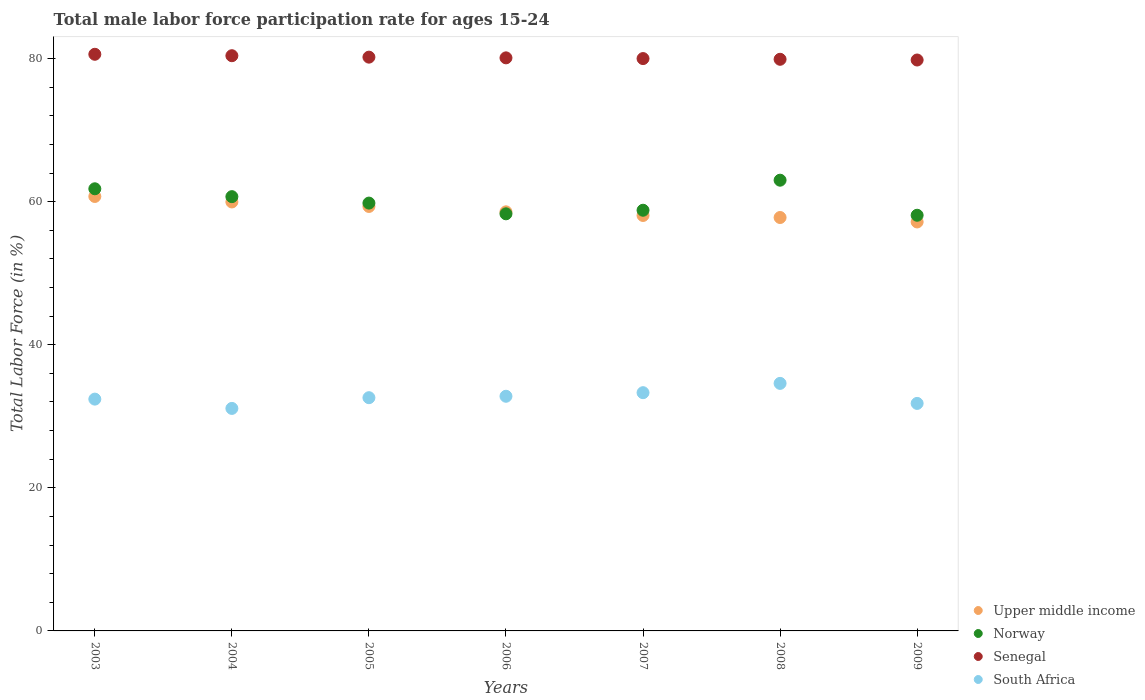What is the male labor force participation rate in Norway in 2005?
Give a very brief answer. 59.8. Across all years, what is the maximum male labor force participation rate in Senegal?
Your answer should be very brief. 80.6. Across all years, what is the minimum male labor force participation rate in Upper middle income?
Your answer should be compact. 57.16. What is the total male labor force participation rate in Senegal in the graph?
Offer a very short reply. 561. What is the difference between the male labor force participation rate in Norway in 2005 and that in 2008?
Provide a succinct answer. -3.2. What is the difference between the male labor force participation rate in Norway in 2006 and the male labor force participation rate in Senegal in 2005?
Your response must be concise. -21.9. What is the average male labor force participation rate in South Africa per year?
Provide a succinct answer. 32.66. In the year 2005, what is the difference between the male labor force participation rate in Upper middle income and male labor force participation rate in Senegal?
Your answer should be very brief. -20.87. What is the ratio of the male labor force participation rate in Norway in 2003 to that in 2005?
Ensure brevity in your answer.  1.03. Is the male labor force participation rate in South Africa in 2005 less than that in 2006?
Offer a terse response. Yes. Is the difference between the male labor force participation rate in Upper middle income in 2006 and 2007 greater than the difference between the male labor force participation rate in Senegal in 2006 and 2007?
Provide a short and direct response. Yes. What is the difference between the highest and the second highest male labor force participation rate in Upper middle income?
Provide a succinct answer. 0.77. What is the difference between the highest and the lowest male labor force participation rate in Norway?
Your response must be concise. 4.9. Is it the case that in every year, the sum of the male labor force participation rate in Senegal and male labor force participation rate in Upper middle income  is greater than the sum of male labor force participation rate in South Africa and male labor force participation rate in Norway?
Offer a terse response. No. Is it the case that in every year, the sum of the male labor force participation rate in South Africa and male labor force participation rate in Senegal  is greater than the male labor force participation rate in Upper middle income?
Offer a very short reply. Yes. Is the male labor force participation rate in Senegal strictly greater than the male labor force participation rate in South Africa over the years?
Give a very brief answer. Yes. How many years are there in the graph?
Provide a succinct answer. 7. Are the values on the major ticks of Y-axis written in scientific E-notation?
Give a very brief answer. No. Does the graph contain any zero values?
Your response must be concise. No. Does the graph contain grids?
Offer a terse response. No. Where does the legend appear in the graph?
Keep it short and to the point. Bottom right. What is the title of the graph?
Provide a succinct answer. Total male labor force participation rate for ages 15-24. Does "Qatar" appear as one of the legend labels in the graph?
Ensure brevity in your answer.  No. What is the label or title of the X-axis?
Ensure brevity in your answer.  Years. What is the label or title of the Y-axis?
Provide a short and direct response. Total Labor Force (in %). What is the Total Labor Force (in %) of Upper middle income in 2003?
Provide a succinct answer. 60.73. What is the Total Labor Force (in %) in Norway in 2003?
Your answer should be very brief. 61.8. What is the Total Labor Force (in %) in Senegal in 2003?
Your answer should be very brief. 80.6. What is the Total Labor Force (in %) in South Africa in 2003?
Provide a short and direct response. 32.4. What is the Total Labor Force (in %) in Upper middle income in 2004?
Give a very brief answer. 59.96. What is the Total Labor Force (in %) of Norway in 2004?
Offer a very short reply. 60.7. What is the Total Labor Force (in %) of Senegal in 2004?
Your answer should be compact. 80.4. What is the Total Labor Force (in %) in South Africa in 2004?
Provide a succinct answer. 31.1. What is the Total Labor Force (in %) of Upper middle income in 2005?
Give a very brief answer. 59.33. What is the Total Labor Force (in %) of Norway in 2005?
Keep it short and to the point. 59.8. What is the Total Labor Force (in %) in Senegal in 2005?
Make the answer very short. 80.2. What is the Total Labor Force (in %) in South Africa in 2005?
Your response must be concise. 32.6. What is the Total Labor Force (in %) of Upper middle income in 2006?
Ensure brevity in your answer.  58.58. What is the Total Labor Force (in %) of Norway in 2006?
Your answer should be compact. 58.3. What is the Total Labor Force (in %) of Senegal in 2006?
Offer a terse response. 80.1. What is the Total Labor Force (in %) of South Africa in 2006?
Offer a very short reply. 32.8. What is the Total Labor Force (in %) of Upper middle income in 2007?
Offer a very short reply. 58.07. What is the Total Labor Force (in %) of Norway in 2007?
Provide a short and direct response. 58.8. What is the Total Labor Force (in %) of South Africa in 2007?
Your response must be concise. 33.3. What is the Total Labor Force (in %) in Upper middle income in 2008?
Ensure brevity in your answer.  57.78. What is the Total Labor Force (in %) of Norway in 2008?
Make the answer very short. 63. What is the Total Labor Force (in %) of Senegal in 2008?
Offer a terse response. 79.9. What is the Total Labor Force (in %) in South Africa in 2008?
Ensure brevity in your answer.  34.6. What is the Total Labor Force (in %) in Upper middle income in 2009?
Offer a terse response. 57.16. What is the Total Labor Force (in %) in Norway in 2009?
Provide a short and direct response. 58.1. What is the Total Labor Force (in %) in Senegal in 2009?
Give a very brief answer. 79.8. What is the Total Labor Force (in %) in South Africa in 2009?
Make the answer very short. 31.8. Across all years, what is the maximum Total Labor Force (in %) in Upper middle income?
Ensure brevity in your answer.  60.73. Across all years, what is the maximum Total Labor Force (in %) of Senegal?
Provide a succinct answer. 80.6. Across all years, what is the maximum Total Labor Force (in %) in South Africa?
Offer a very short reply. 34.6. Across all years, what is the minimum Total Labor Force (in %) in Upper middle income?
Offer a very short reply. 57.16. Across all years, what is the minimum Total Labor Force (in %) in Norway?
Offer a very short reply. 58.1. Across all years, what is the minimum Total Labor Force (in %) in Senegal?
Offer a terse response. 79.8. Across all years, what is the minimum Total Labor Force (in %) of South Africa?
Your answer should be very brief. 31.1. What is the total Total Labor Force (in %) of Upper middle income in the graph?
Offer a terse response. 411.61. What is the total Total Labor Force (in %) of Norway in the graph?
Ensure brevity in your answer.  420.5. What is the total Total Labor Force (in %) of Senegal in the graph?
Your answer should be compact. 561. What is the total Total Labor Force (in %) in South Africa in the graph?
Keep it short and to the point. 228.6. What is the difference between the Total Labor Force (in %) of Upper middle income in 2003 and that in 2004?
Give a very brief answer. 0.77. What is the difference between the Total Labor Force (in %) of Norway in 2003 and that in 2004?
Keep it short and to the point. 1.1. What is the difference between the Total Labor Force (in %) of South Africa in 2003 and that in 2004?
Provide a short and direct response. 1.3. What is the difference between the Total Labor Force (in %) in Upper middle income in 2003 and that in 2005?
Provide a succinct answer. 1.4. What is the difference between the Total Labor Force (in %) in Norway in 2003 and that in 2005?
Your answer should be compact. 2. What is the difference between the Total Labor Force (in %) in Upper middle income in 2003 and that in 2006?
Your response must be concise. 2.15. What is the difference between the Total Labor Force (in %) of Norway in 2003 and that in 2006?
Provide a succinct answer. 3.5. What is the difference between the Total Labor Force (in %) of Senegal in 2003 and that in 2006?
Make the answer very short. 0.5. What is the difference between the Total Labor Force (in %) in South Africa in 2003 and that in 2006?
Keep it short and to the point. -0.4. What is the difference between the Total Labor Force (in %) in Upper middle income in 2003 and that in 2007?
Ensure brevity in your answer.  2.66. What is the difference between the Total Labor Force (in %) of Norway in 2003 and that in 2007?
Offer a very short reply. 3. What is the difference between the Total Labor Force (in %) in Upper middle income in 2003 and that in 2008?
Make the answer very short. 2.94. What is the difference between the Total Labor Force (in %) of Norway in 2003 and that in 2008?
Your response must be concise. -1.2. What is the difference between the Total Labor Force (in %) of Senegal in 2003 and that in 2008?
Provide a short and direct response. 0.7. What is the difference between the Total Labor Force (in %) in Upper middle income in 2003 and that in 2009?
Your answer should be very brief. 3.56. What is the difference between the Total Labor Force (in %) in Norway in 2003 and that in 2009?
Offer a terse response. 3.7. What is the difference between the Total Labor Force (in %) of Senegal in 2003 and that in 2009?
Keep it short and to the point. 0.8. What is the difference between the Total Labor Force (in %) in South Africa in 2003 and that in 2009?
Your response must be concise. 0.6. What is the difference between the Total Labor Force (in %) of Upper middle income in 2004 and that in 2005?
Your answer should be very brief. 0.63. What is the difference between the Total Labor Force (in %) in South Africa in 2004 and that in 2005?
Give a very brief answer. -1.5. What is the difference between the Total Labor Force (in %) in Upper middle income in 2004 and that in 2006?
Give a very brief answer. 1.38. What is the difference between the Total Labor Force (in %) in South Africa in 2004 and that in 2006?
Your response must be concise. -1.7. What is the difference between the Total Labor Force (in %) of Upper middle income in 2004 and that in 2007?
Provide a short and direct response. 1.89. What is the difference between the Total Labor Force (in %) in Norway in 2004 and that in 2007?
Ensure brevity in your answer.  1.9. What is the difference between the Total Labor Force (in %) of Senegal in 2004 and that in 2007?
Your answer should be compact. 0.4. What is the difference between the Total Labor Force (in %) of South Africa in 2004 and that in 2007?
Provide a succinct answer. -2.2. What is the difference between the Total Labor Force (in %) in Upper middle income in 2004 and that in 2008?
Keep it short and to the point. 2.17. What is the difference between the Total Labor Force (in %) of Norway in 2004 and that in 2008?
Your answer should be compact. -2.3. What is the difference between the Total Labor Force (in %) of Senegal in 2004 and that in 2008?
Provide a short and direct response. 0.5. What is the difference between the Total Labor Force (in %) of Upper middle income in 2004 and that in 2009?
Make the answer very short. 2.8. What is the difference between the Total Labor Force (in %) of Upper middle income in 2005 and that in 2006?
Your response must be concise. 0.75. What is the difference between the Total Labor Force (in %) in Senegal in 2005 and that in 2006?
Your response must be concise. 0.1. What is the difference between the Total Labor Force (in %) of Upper middle income in 2005 and that in 2007?
Your answer should be very brief. 1.26. What is the difference between the Total Labor Force (in %) in Senegal in 2005 and that in 2007?
Make the answer very short. 0.2. What is the difference between the Total Labor Force (in %) of South Africa in 2005 and that in 2007?
Give a very brief answer. -0.7. What is the difference between the Total Labor Force (in %) in Upper middle income in 2005 and that in 2008?
Keep it short and to the point. 1.55. What is the difference between the Total Labor Force (in %) in South Africa in 2005 and that in 2008?
Ensure brevity in your answer.  -2. What is the difference between the Total Labor Force (in %) of Upper middle income in 2005 and that in 2009?
Provide a short and direct response. 2.17. What is the difference between the Total Labor Force (in %) in Norway in 2005 and that in 2009?
Offer a very short reply. 1.7. What is the difference between the Total Labor Force (in %) in Senegal in 2005 and that in 2009?
Your answer should be very brief. 0.4. What is the difference between the Total Labor Force (in %) of Upper middle income in 2006 and that in 2007?
Ensure brevity in your answer.  0.51. What is the difference between the Total Labor Force (in %) in Upper middle income in 2006 and that in 2008?
Provide a short and direct response. 0.79. What is the difference between the Total Labor Force (in %) in Norway in 2006 and that in 2008?
Provide a short and direct response. -4.7. What is the difference between the Total Labor Force (in %) of South Africa in 2006 and that in 2008?
Offer a terse response. -1.8. What is the difference between the Total Labor Force (in %) in Upper middle income in 2006 and that in 2009?
Your response must be concise. 1.41. What is the difference between the Total Labor Force (in %) in Norway in 2006 and that in 2009?
Offer a very short reply. 0.2. What is the difference between the Total Labor Force (in %) of Upper middle income in 2007 and that in 2008?
Provide a short and direct response. 0.28. What is the difference between the Total Labor Force (in %) of Senegal in 2007 and that in 2008?
Provide a succinct answer. 0.1. What is the difference between the Total Labor Force (in %) of South Africa in 2007 and that in 2008?
Offer a very short reply. -1.3. What is the difference between the Total Labor Force (in %) of Upper middle income in 2007 and that in 2009?
Your response must be concise. 0.91. What is the difference between the Total Labor Force (in %) in Norway in 2007 and that in 2009?
Offer a very short reply. 0.7. What is the difference between the Total Labor Force (in %) in South Africa in 2007 and that in 2009?
Your answer should be compact. 1.5. What is the difference between the Total Labor Force (in %) in Upper middle income in 2008 and that in 2009?
Offer a terse response. 0.62. What is the difference between the Total Labor Force (in %) in Senegal in 2008 and that in 2009?
Provide a short and direct response. 0.1. What is the difference between the Total Labor Force (in %) in Upper middle income in 2003 and the Total Labor Force (in %) in Norway in 2004?
Your answer should be compact. 0.03. What is the difference between the Total Labor Force (in %) of Upper middle income in 2003 and the Total Labor Force (in %) of Senegal in 2004?
Give a very brief answer. -19.67. What is the difference between the Total Labor Force (in %) in Upper middle income in 2003 and the Total Labor Force (in %) in South Africa in 2004?
Ensure brevity in your answer.  29.63. What is the difference between the Total Labor Force (in %) in Norway in 2003 and the Total Labor Force (in %) in Senegal in 2004?
Make the answer very short. -18.6. What is the difference between the Total Labor Force (in %) of Norway in 2003 and the Total Labor Force (in %) of South Africa in 2004?
Your answer should be compact. 30.7. What is the difference between the Total Labor Force (in %) in Senegal in 2003 and the Total Labor Force (in %) in South Africa in 2004?
Give a very brief answer. 49.5. What is the difference between the Total Labor Force (in %) in Upper middle income in 2003 and the Total Labor Force (in %) in Norway in 2005?
Your answer should be very brief. 0.93. What is the difference between the Total Labor Force (in %) of Upper middle income in 2003 and the Total Labor Force (in %) of Senegal in 2005?
Offer a terse response. -19.47. What is the difference between the Total Labor Force (in %) of Upper middle income in 2003 and the Total Labor Force (in %) of South Africa in 2005?
Offer a terse response. 28.13. What is the difference between the Total Labor Force (in %) of Norway in 2003 and the Total Labor Force (in %) of Senegal in 2005?
Offer a terse response. -18.4. What is the difference between the Total Labor Force (in %) of Norway in 2003 and the Total Labor Force (in %) of South Africa in 2005?
Your answer should be compact. 29.2. What is the difference between the Total Labor Force (in %) of Senegal in 2003 and the Total Labor Force (in %) of South Africa in 2005?
Provide a short and direct response. 48. What is the difference between the Total Labor Force (in %) of Upper middle income in 2003 and the Total Labor Force (in %) of Norway in 2006?
Your answer should be compact. 2.43. What is the difference between the Total Labor Force (in %) of Upper middle income in 2003 and the Total Labor Force (in %) of Senegal in 2006?
Ensure brevity in your answer.  -19.37. What is the difference between the Total Labor Force (in %) in Upper middle income in 2003 and the Total Labor Force (in %) in South Africa in 2006?
Offer a terse response. 27.93. What is the difference between the Total Labor Force (in %) of Norway in 2003 and the Total Labor Force (in %) of Senegal in 2006?
Make the answer very short. -18.3. What is the difference between the Total Labor Force (in %) in Senegal in 2003 and the Total Labor Force (in %) in South Africa in 2006?
Offer a very short reply. 47.8. What is the difference between the Total Labor Force (in %) of Upper middle income in 2003 and the Total Labor Force (in %) of Norway in 2007?
Offer a terse response. 1.93. What is the difference between the Total Labor Force (in %) of Upper middle income in 2003 and the Total Labor Force (in %) of Senegal in 2007?
Give a very brief answer. -19.27. What is the difference between the Total Labor Force (in %) in Upper middle income in 2003 and the Total Labor Force (in %) in South Africa in 2007?
Provide a short and direct response. 27.43. What is the difference between the Total Labor Force (in %) in Norway in 2003 and the Total Labor Force (in %) in Senegal in 2007?
Provide a succinct answer. -18.2. What is the difference between the Total Labor Force (in %) of Norway in 2003 and the Total Labor Force (in %) of South Africa in 2007?
Make the answer very short. 28.5. What is the difference between the Total Labor Force (in %) of Senegal in 2003 and the Total Labor Force (in %) of South Africa in 2007?
Offer a terse response. 47.3. What is the difference between the Total Labor Force (in %) in Upper middle income in 2003 and the Total Labor Force (in %) in Norway in 2008?
Make the answer very short. -2.27. What is the difference between the Total Labor Force (in %) in Upper middle income in 2003 and the Total Labor Force (in %) in Senegal in 2008?
Keep it short and to the point. -19.17. What is the difference between the Total Labor Force (in %) of Upper middle income in 2003 and the Total Labor Force (in %) of South Africa in 2008?
Make the answer very short. 26.13. What is the difference between the Total Labor Force (in %) of Norway in 2003 and the Total Labor Force (in %) of Senegal in 2008?
Provide a succinct answer. -18.1. What is the difference between the Total Labor Force (in %) of Norway in 2003 and the Total Labor Force (in %) of South Africa in 2008?
Give a very brief answer. 27.2. What is the difference between the Total Labor Force (in %) of Upper middle income in 2003 and the Total Labor Force (in %) of Norway in 2009?
Provide a succinct answer. 2.63. What is the difference between the Total Labor Force (in %) in Upper middle income in 2003 and the Total Labor Force (in %) in Senegal in 2009?
Provide a short and direct response. -19.07. What is the difference between the Total Labor Force (in %) of Upper middle income in 2003 and the Total Labor Force (in %) of South Africa in 2009?
Your answer should be compact. 28.93. What is the difference between the Total Labor Force (in %) of Norway in 2003 and the Total Labor Force (in %) of Senegal in 2009?
Give a very brief answer. -18. What is the difference between the Total Labor Force (in %) of Senegal in 2003 and the Total Labor Force (in %) of South Africa in 2009?
Give a very brief answer. 48.8. What is the difference between the Total Labor Force (in %) in Upper middle income in 2004 and the Total Labor Force (in %) in Norway in 2005?
Offer a very short reply. 0.16. What is the difference between the Total Labor Force (in %) in Upper middle income in 2004 and the Total Labor Force (in %) in Senegal in 2005?
Your response must be concise. -20.24. What is the difference between the Total Labor Force (in %) of Upper middle income in 2004 and the Total Labor Force (in %) of South Africa in 2005?
Your answer should be very brief. 27.36. What is the difference between the Total Labor Force (in %) of Norway in 2004 and the Total Labor Force (in %) of Senegal in 2005?
Provide a succinct answer. -19.5. What is the difference between the Total Labor Force (in %) of Norway in 2004 and the Total Labor Force (in %) of South Africa in 2005?
Your answer should be very brief. 28.1. What is the difference between the Total Labor Force (in %) in Senegal in 2004 and the Total Labor Force (in %) in South Africa in 2005?
Provide a short and direct response. 47.8. What is the difference between the Total Labor Force (in %) in Upper middle income in 2004 and the Total Labor Force (in %) in Norway in 2006?
Provide a short and direct response. 1.66. What is the difference between the Total Labor Force (in %) in Upper middle income in 2004 and the Total Labor Force (in %) in Senegal in 2006?
Give a very brief answer. -20.14. What is the difference between the Total Labor Force (in %) in Upper middle income in 2004 and the Total Labor Force (in %) in South Africa in 2006?
Provide a succinct answer. 27.16. What is the difference between the Total Labor Force (in %) in Norway in 2004 and the Total Labor Force (in %) in Senegal in 2006?
Provide a succinct answer. -19.4. What is the difference between the Total Labor Force (in %) in Norway in 2004 and the Total Labor Force (in %) in South Africa in 2006?
Provide a succinct answer. 27.9. What is the difference between the Total Labor Force (in %) of Senegal in 2004 and the Total Labor Force (in %) of South Africa in 2006?
Your answer should be compact. 47.6. What is the difference between the Total Labor Force (in %) of Upper middle income in 2004 and the Total Labor Force (in %) of Norway in 2007?
Your answer should be compact. 1.16. What is the difference between the Total Labor Force (in %) of Upper middle income in 2004 and the Total Labor Force (in %) of Senegal in 2007?
Your response must be concise. -20.04. What is the difference between the Total Labor Force (in %) of Upper middle income in 2004 and the Total Labor Force (in %) of South Africa in 2007?
Offer a very short reply. 26.66. What is the difference between the Total Labor Force (in %) of Norway in 2004 and the Total Labor Force (in %) of Senegal in 2007?
Your answer should be very brief. -19.3. What is the difference between the Total Labor Force (in %) in Norway in 2004 and the Total Labor Force (in %) in South Africa in 2007?
Your answer should be very brief. 27.4. What is the difference between the Total Labor Force (in %) of Senegal in 2004 and the Total Labor Force (in %) of South Africa in 2007?
Provide a short and direct response. 47.1. What is the difference between the Total Labor Force (in %) in Upper middle income in 2004 and the Total Labor Force (in %) in Norway in 2008?
Your answer should be very brief. -3.04. What is the difference between the Total Labor Force (in %) of Upper middle income in 2004 and the Total Labor Force (in %) of Senegal in 2008?
Provide a succinct answer. -19.94. What is the difference between the Total Labor Force (in %) in Upper middle income in 2004 and the Total Labor Force (in %) in South Africa in 2008?
Give a very brief answer. 25.36. What is the difference between the Total Labor Force (in %) of Norway in 2004 and the Total Labor Force (in %) of Senegal in 2008?
Your answer should be compact. -19.2. What is the difference between the Total Labor Force (in %) of Norway in 2004 and the Total Labor Force (in %) of South Africa in 2008?
Keep it short and to the point. 26.1. What is the difference between the Total Labor Force (in %) of Senegal in 2004 and the Total Labor Force (in %) of South Africa in 2008?
Make the answer very short. 45.8. What is the difference between the Total Labor Force (in %) of Upper middle income in 2004 and the Total Labor Force (in %) of Norway in 2009?
Provide a short and direct response. 1.86. What is the difference between the Total Labor Force (in %) in Upper middle income in 2004 and the Total Labor Force (in %) in Senegal in 2009?
Your answer should be compact. -19.84. What is the difference between the Total Labor Force (in %) of Upper middle income in 2004 and the Total Labor Force (in %) of South Africa in 2009?
Provide a short and direct response. 28.16. What is the difference between the Total Labor Force (in %) in Norway in 2004 and the Total Labor Force (in %) in Senegal in 2009?
Provide a short and direct response. -19.1. What is the difference between the Total Labor Force (in %) in Norway in 2004 and the Total Labor Force (in %) in South Africa in 2009?
Offer a terse response. 28.9. What is the difference between the Total Labor Force (in %) of Senegal in 2004 and the Total Labor Force (in %) of South Africa in 2009?
Provide a short and direct response. 48.6. What is the difference between the Total Labor Force (in %) of Upper middle income in 2005 and the Total Labor Force (in %) of Norway in 2006?
Offer a very short reply. 1.03. What is the difference between the Total Labor Force (in %) in Upper middle income in 2005 and the Total Labor Force (in %) in Senegal in 2006?
Your answer should be very brief. -20.77. What is the difference between the Total Labor Force (in %) in Upper middle income in 2005 and the Total Labor Force (in %) in South Africa in 2006?
Ensure brevity in your answer.  26.53. What is the difference between the Total Labor Force (in %) of Norway in 2005 and the Total Labor Force (in %) of Senegal in 2006?
Give a very brief answer. -20.3. What is the difference between the Total Labor Force (in %) in Norway in 2005 and the Total Labor Force (in %) in South Africa in 2006?
Give a very brief answer. 27. What is the difference between the Total Labor Force (in %) in Senegal in 2005 and the Total Labor Force (in %) in South Africa in 2006?
Your response must be concise. 47.4. What is the difference between the Total Labor Force (in %) of Upper middle income in 2005 and the Total Labor Force (in %) of Norway in 2007?
Make the answer very short. 0.53. What is the difference between the Total Labor Force (in %) of Upper middle income in 2005 and the Total Labor Force (in %) of Senegal in 2007?
Keep it short and to the point. -20.67. What is the difference between the Total Labor Force (in %) of Upper middle income in 2005 and the Total Labor Force (in %) of South Africa in 2007?
Offer a very short reply. 26.03. What is the difference between the Total Labor Force (in %) in Norway in 2005 and the Total Labor Force (in %) in Senegal in 2007?
Your answer should be very brief. -20.2. What is the difference between the Total Labor Force (in %) of Senegal in 2005 and the Total Labor Force (in %) of South Africa in 2007?
Offer a terse response. 46.9. What is the difference between the Total Labor Force (in %) in Upper middle income in 2005 and the Total Labor Force (in %) in Norway in 2008?
Provide a short and direct response. -3.67. What is the difference between the Total Labor Force (in %) in Upper middle income in 2005 and the Total Labor Force (in %) in Senegal in 2008?
Provide a succinct answer. -20.57. What is the difference between the Total Labor Force (in %) of Upper middle income in 2005 and the Total Labor Force (in %) of South Africa in 2008?
Make the answer very short. 24.73. What is the difference between the Total Labor Force (in %) of Norway in 2005 and the Total Labor Force (in %) of Senegal in 2008?
Offer a terse response. -20.1. What is the difference between the Total Labor Force (in %) in Norway in 2005 and the Total Labor Force (in %) in South Africa in 2008?
Your answer should be compact. 25.2. What is the difference between the Total Labor Force (in %) in Senegal in 2005 and the Total Labor Force (in %) in South Africa in 2008?
Offer a terse response. 45.6. What is the difference between the Total Labor Force (in %) in Upper middle income in 2005 and the Total Labor Force (in %) in Norway in 2009?
Offer a terse response. 1.23. What is the difference between the Total Labor Force (in %) in Upper middle income in 2005 and the Total Labor Force (in %) in Senegal in 2009?
Ensure brevity in your answer.  -20.47. What is the difference between the Total Labor Force (in %) of Upper middle income in 2005 and the Total Labor Force (in %) of South Africa in 2009?
Your answer should be compact. 27.53. What is the difference between the Total Labor Force (in %) in Senegal in 2005 and the Total Labor Force (in %) in South Africa in 2009?
Your answer should be very brief. 48.4. What is the difference between the Total Labor Force (in %) of Upper middle income in 2006 and the Total Labor Force (in %) of Norway in 2007?
Offer a very short reply. -0.22. What is the difference between the Total Labor Force (in %) of Upper middle income in 2006 and the Total Labor Force (in %) of Senegal in 2007?
Keep it short and to the point. -21.42. What is the difference between the Total Labor Force (in %) in Upper middle income in 2006 and the Total Labor Force (in %) in South Africa in 2007?
Your response must be concise. 25.28. What is the difference between the Total Labor Force (in %) of Norway in 2006 and the Total Labor Force (in %) of Senegal in 2007?
Make the answer very short. -21.7. What is the difference between the Total Labor Force (in %) in Norway in 2006 and the Total Labor Force (in %) in South Africa in 2007?
Your answer should be very brief. 25. What is the difference between the Total Labor Force (in %) of Senegal in 2006 and the Total Labor Force (in %) of South Africa in 2007?
Provide a short and direct response. 46.8. What is the difference between the Total Labor Force (in %) of Upper middle income in 2006 and the Total Labor Force (in %) of Norway in 2008?
Keep it short and to the point. -4.42. What is the difference between the Total Labor Force (in %) of Upper middle income in 2006 and the Total Labor Force (in %) of Senegal in 2008?
Keep it short and to the point. -21.32. What is the difference between the Total Labor Force (in %) in Upper middle income in 2006 and the Total Labor Force (in %) in South Africa in 2008?
Your response must be concise. 23.98. What is the difference between the Total Labor Force (in %) of Norway in 2006 and the Total Labor Force (in %) of Senegal in 2008?
Make the answer very short. -21.6. What is the difference between the Total Labor Force (in %) in Norway in 2006 and the Total Labor Force (in %) in South Africa in 2008?
Your answer should be very brief. 23.7. What is the difference between the Total Labor Force (in %) in Senegal in 2006 and the Total Labor Force (in %) in South Africa in 2008?
Keep it short and to the point. 45.5. What is the difference between the Total Labor Force (in %) in Upper middle income in 2006 and the Total Labor Force (in %) in Norway in 2009?
Provide a succinct answer. 0.48. What is the difference between the Total Labor Force (in %) of Upper middle income in 2006 and the Total Labor Force (in %) of Senegal in 2009?
Make the answer very short. -21.22. What is the difference between the Total Labor Force (in %) in Upper middle income in 2006 and the Total Labor Force (in %) in South Africa in 2009?
Your answer should be very brief. 26.78. What is the difference between the Total Labor Force (in %) of Norway in 2006 and the Total Labor Force (in %) of Senegal in 2009?
Your answer should be compact. -21.5. What is the difference between the Total Labor Force (in %) in Senegal in 2006 and the Total Labor Force (in %) in South Africa in 2009?
Ensure brevity in your answer.  48.3. What is the difference between the Total Labor Force (in %) in Upper middle income in 2007 and the Total Labor Force (in %) in Norway in 2008?
Provide a succinct answer. -4.93. What is the difference between the Total Labor Force (in %) of Upper middle income in 2007 and the Total Labor Force (in %) of Senegal in 2008?
Provide a short and direct response. -21.83. What is the difference between the Total Labor Force (in %) in Upper middle income in 2007 and the Total Labor Force (in %) in South Africa in 2008?
Ensure brevity in your answer.  23.47. What is the difference between the Total Labor Force (in %) of Norway in 2007 and the Total Labor Force (in %) of Senegal in 2008?
Make the answer very short. -21.1. What is the difference between the Total Labor Force (in %) in Norway in 2007 and the Total Labor Force (in %) in South Africa in 2008?
Your response must be concise. 24.2. What is the difference between the Total Labor Force (in %) of Senegal in 2007 and the Total Labor Force (in %) of South Africa in 2008?
Give a very brief answer. 45.4. What is the difference between the Total Labor Force (in %) in Upper middle income in 2007 and the Total Labor Force (in %) in Norway in 2009?
Your answer should be very brief. -0.03. What is the difference between the Total Labor Force (in %) in Upper middle income in 2007 and the Total Labor Force (in %) in Senegal in 2009?
Provide a succinct answer. -21.73. What is the difference between the Total Labor Force (in %) in Upper middle income in 2007 and the Total Labor Force (in %) in South Africa in 2009?
Keep it short and to the point. 26.27. What is the difference between the Total Labor Force (in %) of Norway in 2007 and the Total Labor Force (in %) of Senegal in 2009?
Give a very brief answer. -21. What is the difference between the Total Labor Force (in %) of Senegal in 2007 and the Total Labor Force (in %) of South Africa in 2009?
Provide a short and direct response. 48.2. What is the difference between the Total Labor Force (in %) in Upper middle income in 2008 and the Total Labor Force (in %) in Norway in 2009?
Offer a very short reply. -0.32. What is the difference between the Total Labor Force (in %) of Upper middle income in 2008 and the Total Labor Force (in %) of Senegal in 2009?
Your response must be concise. -22.02. What is the difference between the Total Labor Force (in %) in Upper middle income in 2008 and the Total Labor Force (in %) in South Africa in 2009?
Ensure brevity in your answer.  25.98. What is the difference between the Total Labor Force (in %) of Norway in 2008 and the Total Labor Force (in %) of Senegal in 2009?
Your answer should be compact. -16.8. What is the difference between the Total Labor Force (in %) of Norway in 2008 and the Total Labor Force (in %) of South Africa in 2009?
Provide a short and direct response. 31.2. What is the difference between the Total Labor Force (in %) of Senegal in 2008 and the Total Labor Force (in %) of South Africa in 2009?
Offer a terse response. 48.1. What is the average Total Labor Force (in %) in Upper middle income per year?
Offer a very short reply. 58.8. What is the average Total Labor Force (in %) of Norway per year?
Offer a very short reply. 60.07. What is the average Total Labor Force (in %) in Senegal per year?
Give a very brief answer. 80.14. What is the average Total Labor Force (in %) in South Africa per year?
Ensure brevity in your answer.  32.66. In the year 2003, what is the difference between the Total Labor Force (in %) in Upper middle income and Total Labor Force (in %) in Norway?
Provide a succinct answer. -1.07. In the year 2003, what is the difference between the Total Labor Force (in %) of Upper middle income and Total Labor Force (in %) of Senegal?
Your answer should be compact. -19.87. In the year 2003, what is the difference between the Total Labor Force (in %) of Upper middle income and Total Labor Force (in %) of South Africa?
Your answer should be very brief. 28.33. In the year 2003, what is the difference between the Total Labor Force (in %) in Norway and Total Labor Force (in %) in Senegal?
Make the answer very short. -18.8. In the year 2003, what is the difference between the Total Labor Force (in %) in Norway and Total Labor Force (in %) in South Africa?
Give a very brief answer. 29.4. In the year 2003, what is the difference between the Total Labor Force (in %) of Senegal and Total Labor Force (in %) of South Africa?
Keep it short and to the point. 48.2. In the year 2004, what is the difference between the Total Labor Force (in %) in Upper middle income and Total Labor Force (in %) in Norway?
Provide a succinct answer. -0.74. In the year 2004, what is the difference between the Total Labor Force (in %) of Upper middle income and Total Labor Force (in %) of Senegal?
Your response must be concise. -20.44. In the year 2004, what is the difference between the Total Labor Force (in %) in Upper middle income and Total Labor Force (in %) in South Africa?
Provide a succinct answer. 28.86. In the year 2004, what is the difference between the Total Labor Force (in %) of Norway and Total Labor Force (in %) of Senegal?
Offer a terse response. -19.7. In the year 2004, what is the difference between the Total Labor Force (in %) in Norway and Total Labor Force (in %) in South Africa?
Give a very brief answer. 29.6. In the year 2004, what is the difference between the Total Labor Force (in %) in Senegal and Total Labor Force (in %) in South Africa?
Give a very brief answer. 49.3. In the year 2005, what is the difference between the Total Labor Force (in %) of Upper middle income and Total Labor Force (in %) of Norway?
Make the answer very short. -0.47. In the year 2005, what is the difference between the Total Labor Force (in %) of Upper middle income and Total Labor Force (in %) of Senegal?
Your response must be concise. -20.87. In the year 2005, what is the difference between the Total Labor Force (in %) of Upper middle income and Total Labor Force (in %) of South Africa?
Ensure brevity in your answer.  26.73. In the year 2005, what is the difference between the Total Labor Force (in %) of Norway and Total Labor Force (in %) of Senegal?
Your response must be concise. -20.4. In the year 2005, what is the difference between the Total Labor Force (in %) in Norway and Total Labor Force (in %) in South Africa?
Your response must be concise. 27.2. In the year 2005, what is the difference between the Total Labor Force (in %) of Senegal and Total Labor Force (in %) of South Africa?
Provide a succinct answer. 47.6. In the year 2006, what is the difference between the Total Labor Force (in %) in Upper middle income and Total Labor Force (in %) in Norway?
Provide a short and direct response. 0.28. In the year 2006, what is the difference between the Total Labor Force (in %) of Upper middle income and Total Labor Force (in %) of Senegal?
Keep it short and to the point. -21.52. In the year 2006, what is the difference between the Total Labor Force (in %) of Upper middle income and Total Labor Force (in %) of South Africa?
Your answer should be very brief. 25.78. In the year 2006, what is the difference between the Total Labor Force (in %) of Norway and Total Labor Force (in %) of Senegal?
Your answer should be compact. -21.8. In the year 2006, what is the difference between the Total Labor Force (in %) in Norway and Total Labor Force (in %) in South Africa?
Keep it short and to the point. 25.5. In the year 2006, what is the difference between the Total Labor Force (in %) of Senegal and Total Labor Force (in %) of South Africa?
Give a very brief answer. 47.3. In the year 2007, what is the difference between the Total Labor Force (in %) in Upper middle income and Total Labor Force (in %) in Norway?
Offer a terse response. -0.73. In the year 2007, what is the difference between the Total Labor Force (in %) in Upper middle income and Total Labor Force (in %) in Senegal?
Offer a very short reply. -21.93. In the year 2007, what is the difference between the Total Labor Force (in %) in Upper middle income and Total Labor Force (in %) in South Africa?
Provide a short and direct response. 24.77. In the year 2007, what is the difference between the Total Labor Force (in %) of Norway and Total Labor Force (in %) of Senegal?
Your answer should be compact. -21.2. In the year 2007, what is the difference between the Total Labor Force (in %) in Senegal and Total Labor Force (in %) in South Africa?
Keep it short and to the point. 46.7. In the year 2008, what is the difference between the Total Labor Force (in %) in Upper middle income and Total Labor Force (in %) in Norway?
Make the answer very short. -5.22. In the year 2008, what is the difference between the Total Labor Force (in %) of Upper middle income and Total Labor Force (in %) of Senegal?
Your answer should be very brief. -22.12. In the year 2008, what is the difference between the Total Labor Force (in %) in Upper middle income and Total Labor Force (in %) in South Africa?
Your answer should be compact. 23.18. In the year 2008, what is the difference between the Total Labor Force (in %) of Norway and Total Labor Force (in %) of Senegal?
Provide a succinct answer. -16.9. In the year 2008, what is the difference between the Total Labor Force (in %) in Norway and Total Labor Force (in %) in South Africa?
Your answer should be very brief. 28.4. In the year 2008, what is the difference between the Total Labor Force (in %) in Senegal and Total Labor Force (in %) in South Africa?
Offer a very short reply. 45.3. In the year 2009, what is the difference between the Total Labor Force (in %) in Upper middle income and Total Labor Force (in %) in Norway?
Provide a short and direct response. -0.94. In the year 2009, what is the difference between the Total Labor Force (in %) in Upper middle income and Total Labor Force (in %) in Senegal?
Your answer should be very brief. -22.64. In the year 2009, what is the difference between the Total Labor Force (in %) of Upper middle income and Total Labor Force (in %) of South Africa?
Offer a terse response. 25.36. In the year 2009, what is the difference between the Total Labor Force (in %) of Norway and Total Labor Force (in %) of Senegal?
Offer a very short reply. -21.7. In the year 2009, what is the difference between the Total Labor Force (in %) in Norway and Total Labor Force (in %) in South Africa?
Ensure brevity in your answer.  26.3. In the year 2009, what is the difference between the Total Labor Force (in %) in Senegal and Total Labor Force (in %) in South Africa?
Make the answer very short. 48. What is the ratio of the Total Labor Force (in %) of Upper middle income in 2003 to that in 2004?
Your response must be concise. 1.01. What is the ratio of the Total Labor Force (in %) of Norway in 2003 to that in 2004?
Ensure brevity in your answer.  1.02. What is the ratio of the Total Labor Force (in %) of Senegal in 2003 to that in 2004?
Your answer should be very brief. 1. What is the ratio of the Total Labor Force (in %) in South Africa in 2003 to that in 2004?
Your answer should be very brief. 1.04. What is the ratio of the Total Labor Force (in %) of Upper middle income in 2003 to that in 2005?
Ensure brevity in your answer.  1.02. What is the ratio of the Total Labor Force (in %) in Norway in 2003 to that in 2005?
Keep it short and to the point. 1.03. What is the ratio of the Total Labor Force (in %) of Senegal in 2003 to that in 2005?
Offer a very short reply. 1. What is the ratio of the Total Labor Force (in %) in South Africa in 2003 to that in 2005?
Provide a succinct answer. 0.99. What is the ratio of the Total Labor Force (in %) of Upper middle income in 2003 to that in 2006?
Provide a short and direct response. 1.04. What is the ratio of the Total Labor Force (in %) in Norway in 2003 to that in 2006?
Make the answer very short. 1.06. What is the ratio of the Total Labor Force (in %) in Senegal in 2003 to that in 2006?
Ensure brevity in your answer.  1.01. What is the ratio of the Total Labor Force (in %) of Upper middle income in 2003 to that in 2007?
Give a very brief answer. 1.05. What is the ratio of the Total Labor Force (in %) of Norway in 2003 to that in 2007?
Keep it short and to the point. 1.05. What is the ratio of the Total Labor Force (in %) in Senegal in 2003 to that in 2007?
Offer a terse response. 1.01. What is the ratio of the Total Labor Force (in %) of Upper middle income in 2003 to that in 2008?
Your answer should be very brief. 1.05. What is the ratio of the Total Labor Force (in %) of Norway in 2003 to that in 2008?
Provide a succinct answer. 0.98. What is the ratio of the Total Labor Force (in %) of Senegal in 2003 to that in 2008?
Offer a very short reply. 1.01. What is the ratio of the Total Labor Force (in %) in South Africa in 2003 to that in 2008?
Your answer should be compact. 0.94. What is the ratio of the Total Labor Force (in %) in Upper middle income in 2003 to that in 2009?
Your answer should be very brief. 1.06. What is the ratio of the Total Labor Force (in %) in Norway in 2003 to that in 2009?
Provide a succinct answer. 1.06. What is the ratio of the Total Labor Force (in %) of Senegal in 2003 to that in 2009?
Give a very brief answer. 1.01. What is the ratio of the Total Labor Force (in %) of South Africa in 2003 to that in 2009?
Make the answer very short. 1.02. What is the ratio of the Total Labor Force (in %) in Upper middle income in 2004 to that in 2005?
Provide a short and direct response. 1.01. What is the ratio of the Total Labor Force (in %) in Norway in 2004 to that in 2005?
Offer a very short reply. 1.02. What is the ratio of the Total Labor Force (in %) of Senegal in 2004 to that in 2005?
Your response must be concise. 1. What is the ratio of the Total Labor Force (in %) of South Africa in 2004 to that in 2005?
Give a very brief answer. 0.95. What is the ratio of the Total Labor Force (in %) of Upper middle income in 2004 to that in 2006?
Your answer should be compact. 1.02. What is the ratio of the Total Labor Force (in %) of Norway in 2004 to that in 2006?
Provide a short and direct response. 1.04. What is the ratio of the Total Labor Force (in %) of Senegal in 2004 to that in 2006?
Provide a succinct answer. 1. What is the ratio of the Total Labor Force (in %) in South Africa in 2004 to that in 2006?
Offer a terse response. 0.95. What is the ratio of the Total Labor Force (in %) in Upper middle income in 2004 to that in 2007?
Offer a very short reply. 1.03. What is the ratio of the Total Labor Force (in %) of Norway in 2004 to that in 2007?
Provide a succinct answer. 1.03. What is the ratio of the Total Labor Force (in %) of Senegal in 2004 to that in 2007?
Provide a short and direct response. 1. What is the ratio of the Total Labor Force (in %) in South Africa in 2004 to that in 2007?
Your answer should be compact. 0.93. What is the ratio of the Total Labor Force (in %) of Upper middle income in 2004 to that in 2008?
Offer a very short reply. 1.04. What is the ratio of the Total Labor Force (in %) in Norway in 2004 to that in 2008?
Ensure brevity in your answer.  0.96. What is the ratio of the Total Labor Force (in %) of Senegal in 2004 to that in 2008?
Make the answer very short. 1.01. What is the ratio of the Total Labor Force (in %) in South Africa in 2004 to that in 2008?
Keep it short and to the point. 0.9. What is the ratio of the Total Labor Force (in %) of Upper middle income in 2004 to that in 2009?
Ensure brevity in your answer.  1.05. What is the ratio of the Total Labor Force (in %) of Norway in 2004 to that in 2009?
Ensure brevity in your answer.  1.04. What is the ratio of the Total Labor Force (in %) in Senegal in 2004 to that in 2009?
Offer a very short reply. 1.01. What is the ratio of the Total Labor Force (in %) in South Africa in 2004 to that in 2009?
Your answer should be very brief. 0.98. What is the ratio of the Total Labor Force (in %) in Upper middle income in 2005 to that in 2006?
Offer a terse response. 1.01. What is the ratio of the Total Labor Force (in %) in Norway in 2005 to that in 2006?
Offer a very short reply. 1.03. What is the ratio of the Total Labor Force (in %) in Senegal in 2005 to that in 2006?
Your response must be concise. 1. What is the ratio of the Total Labor Force (in %) in Upper middle income in 2005 to that in 2007?
Provide a succinct answer. 1.02. What is the ratio of the Total Labor Force (in %) in Senegal in 2005 to that in 2007?
Provide a short and direct response. 1. What is the ratio of the Total Labor Force (in %) of Upper middle income in 2005 to that in 2008?
Offer a very short reply. 1.03. What is the ratio of the Total Labor Force (in %) in Norway in 2005 to that in 2008?
Your answer should be very brief. 0.95. What is the ratio of the Total Labor Force (in %) of South Africa in 2005 to that in 2008?
Offer a very short reply. 0.94. What is the ratio of the Total Labor Force (in %) of Upper middle income in 2005 to that in 2009?
Offer a terse response. 1.04. What is the ratio of the Total Labor Force (in %) in Norway in 2005 to that in 2009?
Provide a succinct answer. 1.03. What is the ratio of the Total Labor Force (in %) of Senegal in 2005 to that in 2009?
Keep it short and to the point. 1. What is the ratio of the Total Labor Force (in %) in South Africa in 2005 to that in 2009?
Keep it short and to the point. 1.03. What is the ratio of the Total Labor Force (in %) in Upper middle income in 2006 to that in 2007?
Ensure brevity in your answer.  1.01. What is the ratio of the Total Labor Force (in %) of Upper middle income in 2006 to that in 2008?
Provide a short and direct response. 1.01. What is the ratio of the Total Labor Force (in %) of Norway in 2006 to that in 2008?
Provide a succinct answer. 0.93. What is the ratio of the Total Labor Force (in %) in South Africa in 2006 to that in 2008?
Make the answer very short. 0.95. What is the ratio of the Total Labor Force (in %) in Upper middle income in 2006 to that in 2009?
Your response must be concise. 1.02. What is the ratio of the Total Labor Force (in %) of Senegal in 2006 to that in 2009?
Make the answer very short. 1. What is the ratio of the Total Labor Force (in %) of South Africa in 2006 to that in 2009?
Make the answer very short. 1.03. What is the ratio of the Total Labor Force (in %) in Senegal in 2007 to that in 2008?
Your answer should be compact. 1. What is the ratio of the Total Labor Force (in %) in South Africa in 2007 to that in 2008?
Your answer should be compact. 0.96. What is the ratio of the Total Labor Force (in %) of Upper middle income in 2007 to that in 2009?
Provide a short and direct response. 1.02. What is the ratio of the Total Labor Force (in %) of Norway in 2007 to that in 2009?
Give a very brief answer. 1.01. What is the ratio of the Total Labor Force (in %) of Senegal in 2007 to that in 2009?
Your answer should be compact. 1. What is the ratio of the Total Labor Force (in %) of South Africa in 2007 to that in 2009?
Keep it short and to the point. 1.05. What is the ratio of the Total Labor Force (in %) of Upper middle income in 2008 to that in 2009?
Make the answer very short. 1.01. What is the ratio of the Total Labor Force (in %) of Norway in 2008 to that in 2009?
Your response must be concise. 1.08. What is the ratio of the Total Labor Force (in %) of Senegal in 2008 to that in 2009?
Offer a very short reply. 1. What is the ratio of the Total Labor Force (in %) in South Africa in 2008 to that in 2009?
Keep it short and to the point. 1.09. What is the difference between the highest and the second highest Total Labor Force (in %) in Upper middle income?
Keep it short and to the point. 0.77. What is the difference between the highest and the second highest Total Labor Force (in %) of Senegal?
Provide a short and direct response. 0.2. What is the difference between the highest and the lowest Total Labor Force (in %) of Upper middle income?
Your response must be concise. 3.56. What is the difference between the highest and the lowest Total Labor Force (in %) of South Africa?
Make the answer very short. 3.5. 